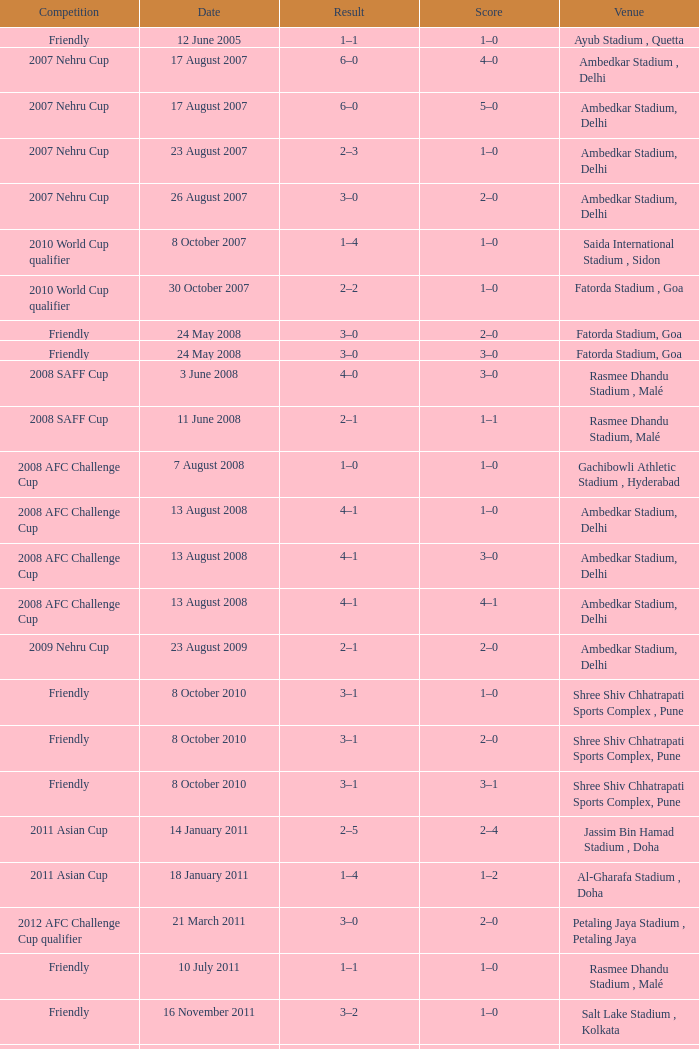Tell me the score on 22 august 2012 1–0. 